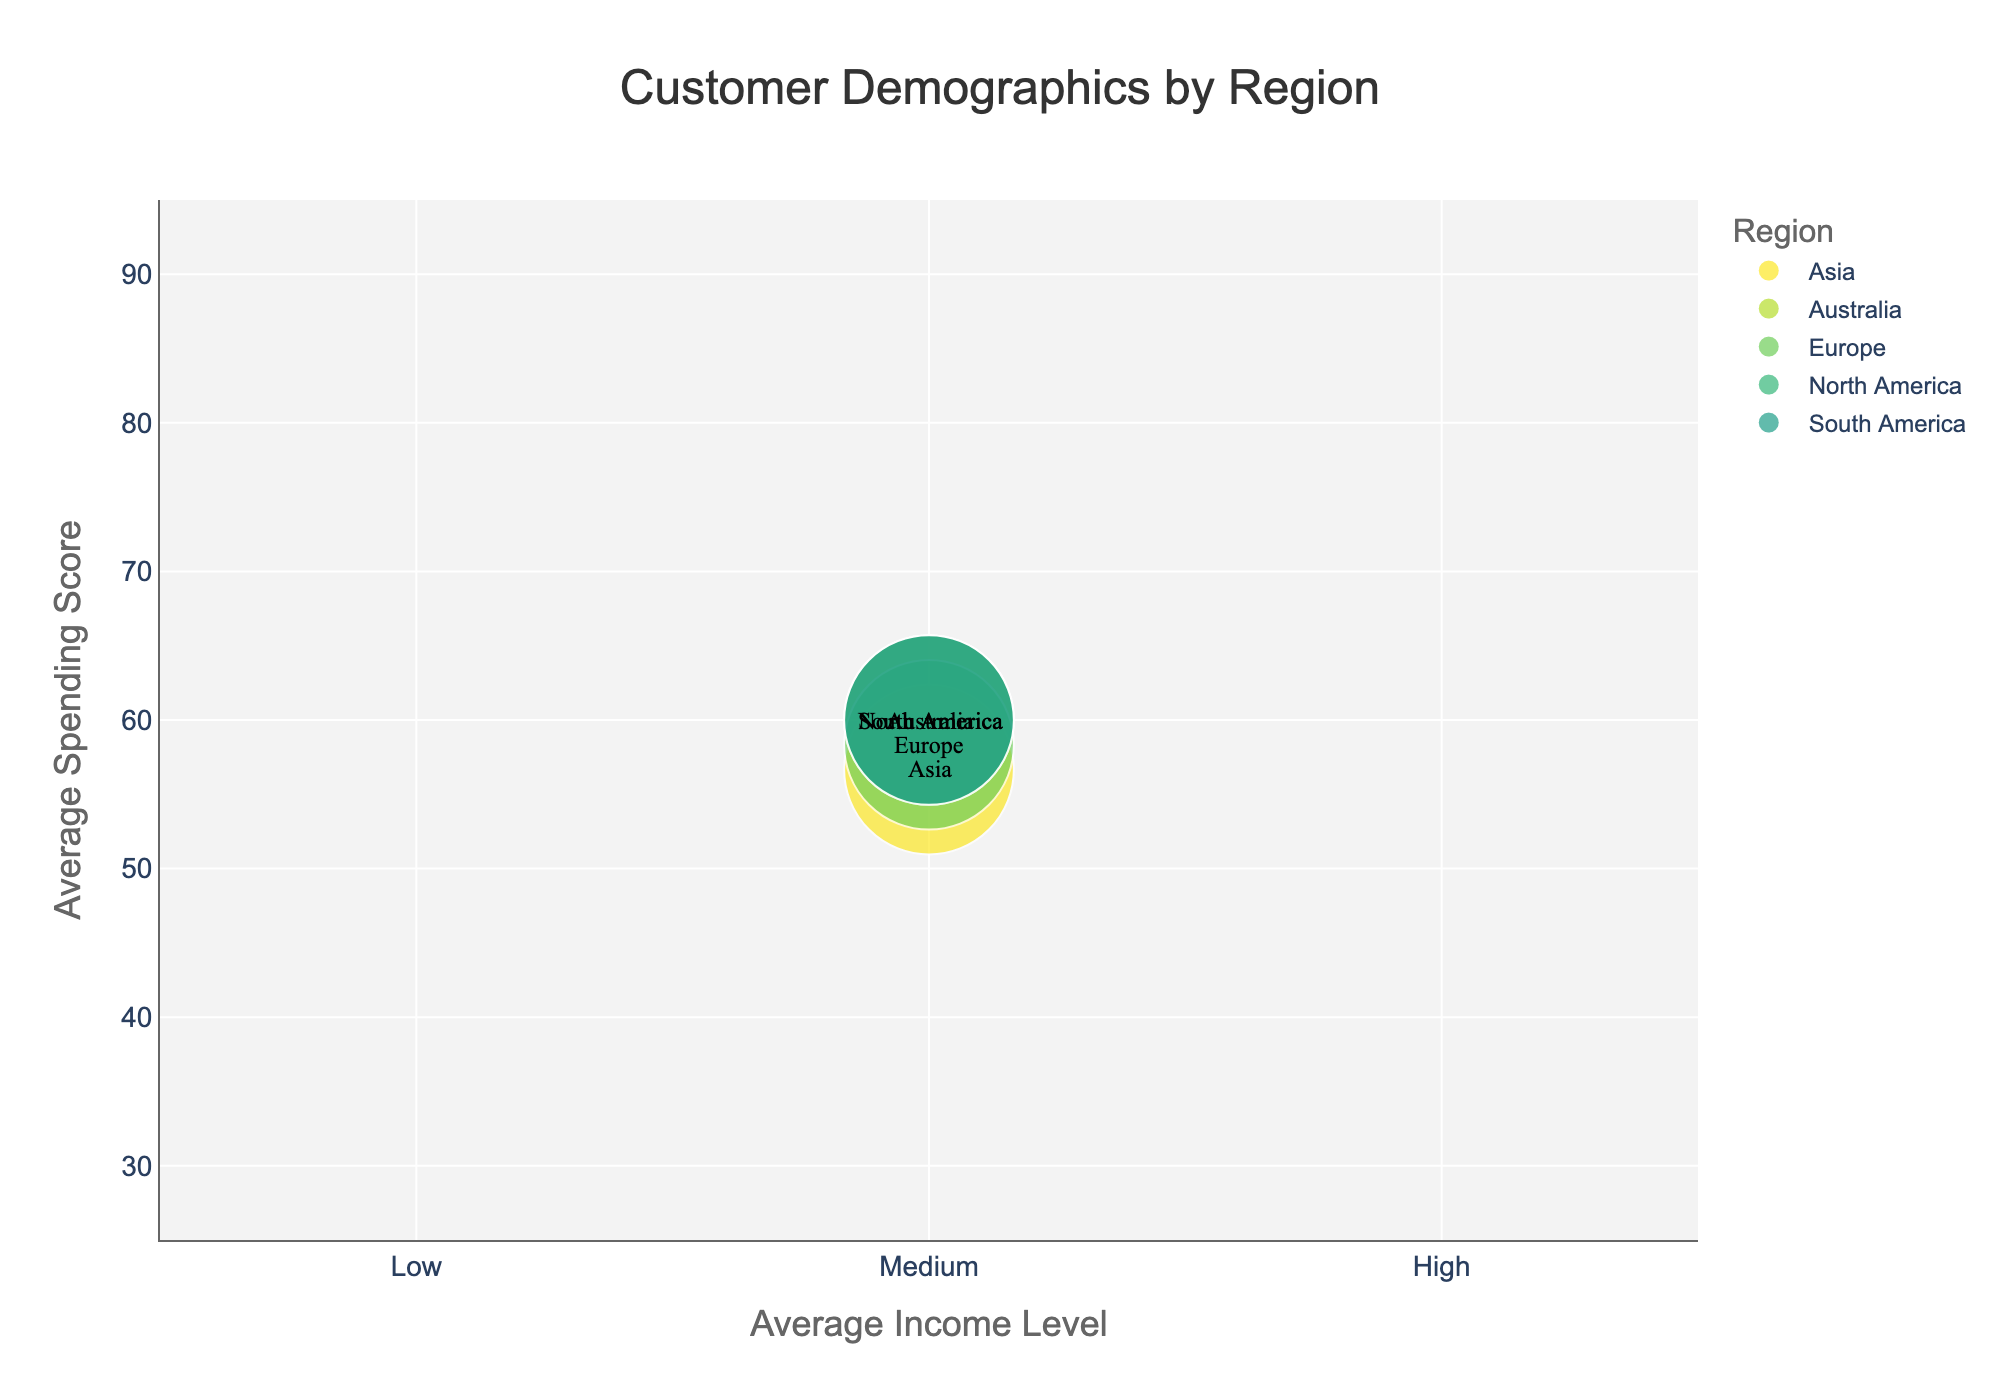What is the title of the bubble chart? The title is typically located at the top center of the chart and it's represented with larger text. In this case, the title reads: "Customer Demographics by Region".
Answer: Customer Demographics by Region What does the x-axis represent? The x-axis is labeled with the title "Average Income Level", which provides information on the average income level of customers in different regions.
Answer: Average Income Level Which region has the highest average spending score? By examining the y-axis, which represents spending scores, we observe that the Europe region has the highest value, specifically around 90.
Answer: Europe Which region has the lowest average income level? We can determine the lowest average income level by looking at the x-axis positions and seeing which region's bubble is the furthest to the left. The Europe region, with an approximate value close to 2.0, has the lowest average income level among the regions.
Answer: Europe How does the size of the bubbles relate to the data? The size of the bubbles reflects the count of customers in each region. Larger bubbles indicate a higher number of customers, while smaller bubbles denote fewer customers.
Answer: Number of customers What is the average income level and average spending score for the South America region? The South America bubble is about at x=2.67 for income level and y=60 for spending score. These values represent South America's average income level and spending score.
Answer: Average income level: 2.67, Average spending score: 60 Which region has more customers, North America or Asia? The size of the bubble indicates the number of customers. North America's bubble is larger than Asia's bubble, meaning North America has more customers.
Answer: North America Compare the average income levels of the North America and Australia regions. Which one is higher? The North America and Australia bubbles are around 2.0 and 2.33 on the x-axis, respectively. Therefore, Australia has a higher average income level compared to North America.
Answer: Australia How many regions are displayed in the bubble chart? We can count the number of distinct colored bubbles in the chart. There are five bubbles, each representing a different region.
Answer: Five 